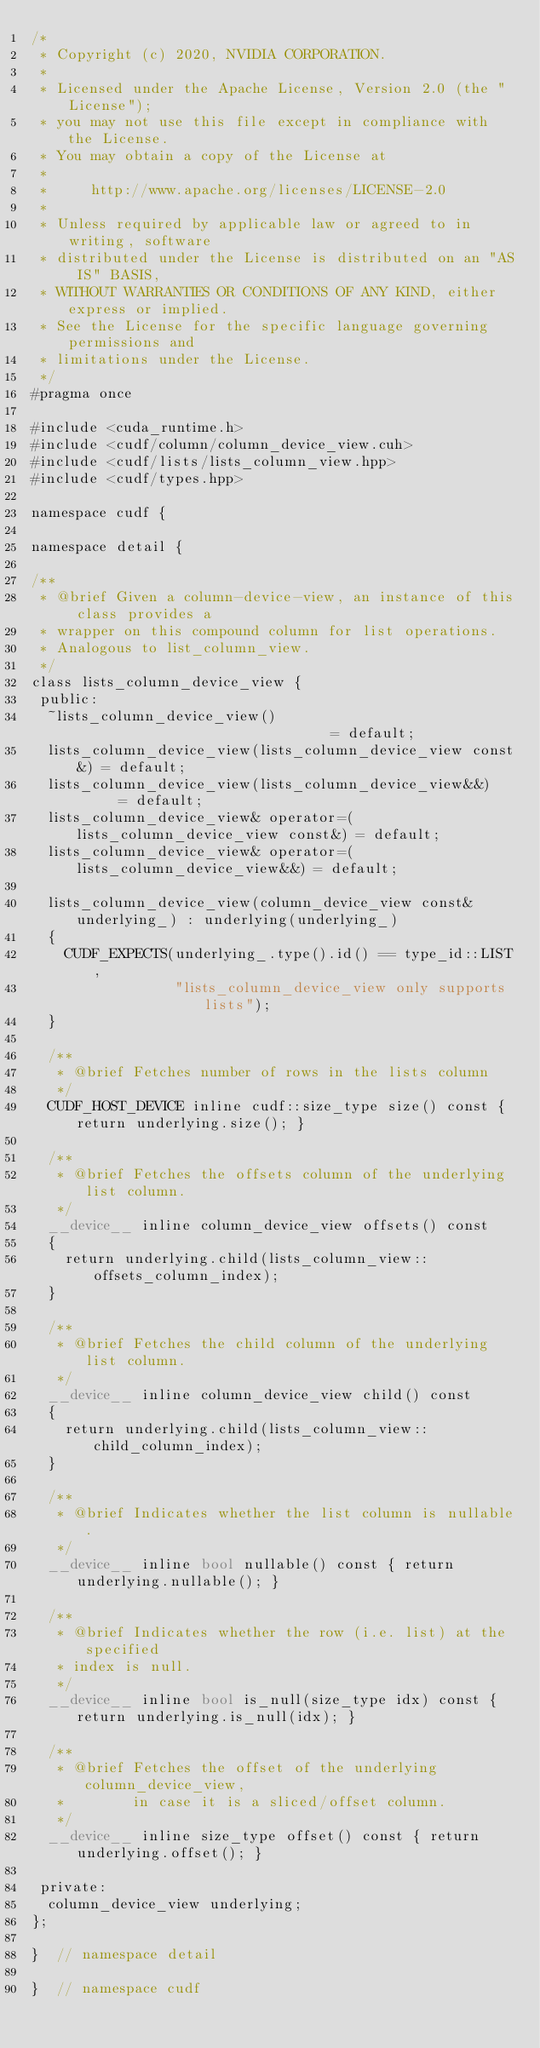Convert code to text. <code><loc_0><loc_0><loc_500><loc_500><_Cuda_>/*
 * Copyright (c) 2020, NVIDIA CORPORATION.
 *
 * Licensed under the Apache License, Version 2.0 (the "License");
 * you may not use this file except in compliance with the License.
 * You may obtain a copy of the License at
 *
 *     http://www.apache.org/licenses/LICENSE-2.0
 *
 * Unless required by applicable law or agreed to in writing, software
 * distributed under the License is distributed on an "AS IS" BASIS,
 * WITHOUT WARRANTIES OR CONDITIONS OF ANY KIND, either express or implied.
 * See the License for the specific language governing permissions and
 * limitations under the License.
 */
#pragma once

#include <cuda_runtime.h>
#include <cudf/column/column_device_view.cuh>
#include <cudf/lists/lists_column_view.hpp>
#include <cudf/types.hpp>

namespace cudf {

namespace detail {

/**
 * @brief Given a column-device-view, an instance of this class provides a
 * wrapper on this compound column for list operations.
 * Analogous to list_column_view.
 */
class lists_column_device_view {
 public:
  ~lists_column_device_view()                               = default;
  lists_column_device_view(lists_column_device_view const&) = default;
  lists_column_device_view(lists_column_device_view&&)      = default;
  lists_column_device_view& operator=(lists_column_device_view const&) = default;
  lists_column_device_view& operator=(lists_column_device_view&&) = default;

  lists_column_device_view(column_device_view const& underlying_) : underlying(underlying_)
  {
    CUDF_EXPECTS(underlying_.type().id() == type_id::LIST,
                 "lists_column_device_view only supports lists");
  }

  /**
   * @brief Fetches number of rows in the lists column
   */
  CUDF_HOST_DEVICE inline cudf::size_type size() const { return underlying.size(); }

  /**
   * @brief Fetches the offsets column of the underlying list column.
   */
  __device__ inline column_device_view offsets() const
  {
    return underlying.child(lists_column_view::offsets_column_index);
  }

  /**
   * @brief Fetches the child column of the underlying list column.
   */
  __device__ inline column_device_view child() const
  {
    return underlying.child(lists_column_view::child_column_index);
  }

  /**
   * @brief Indicates whether the list column is nullable.
   */
  __device__ inline bool nullable() const { return underlying.nullable(); }

  /**
   * @brief Indicates whether the row (i.e. list) at the specified
   * index is null.
   */
  __device__ inline bool is_null(size_type idx) const { return underlying.is_null(idx); }

  /**
   * @brief Fetches the offset of the underlying column_device_view,
   *        in case it is a sliced/offset column.
   */
  __device__ inline size_type offset() const { return underlying.offset(); }

 private:
  column_device_view underlying;
};

}  // namespace detail

}  // namespace cudf
</code> 